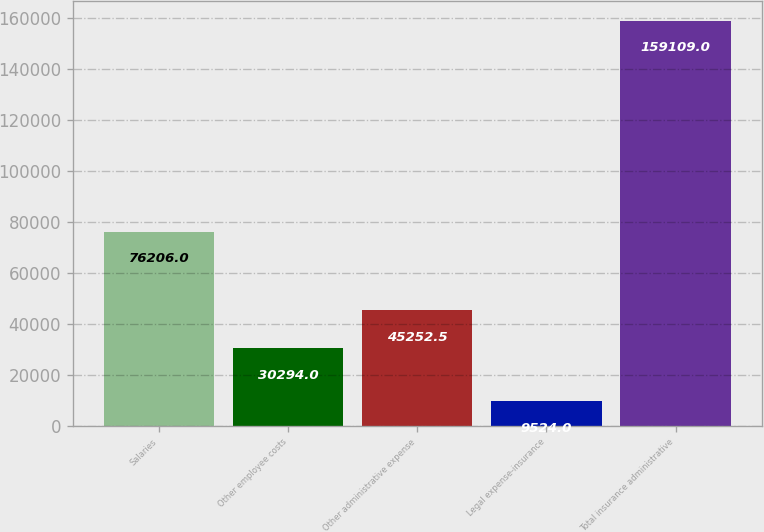Convert chart to OTSL. <chart><loc_0><loc_0><loc_500><loc_500><bar_chart><fcel>Salaries<fcel>Other employee costs<fcel>Other administrative expense<fcel>Legal expense-insurance<fcel>Total insurance administrative<nl><fcel>76206<fcel>30294<fcel>45252.5<fcel>9524<fcel>159109<nl></chart> 